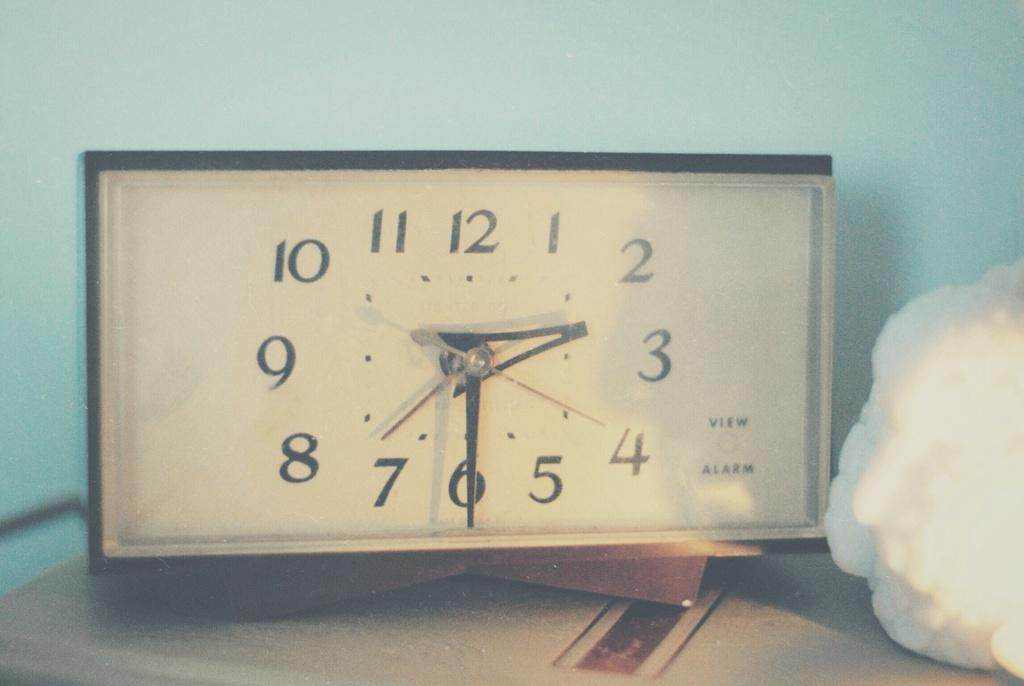<image>
Give a short and clear explanation of the subsequent image. A vintage alarm clock that says view and alarm in the bottom right corner. 